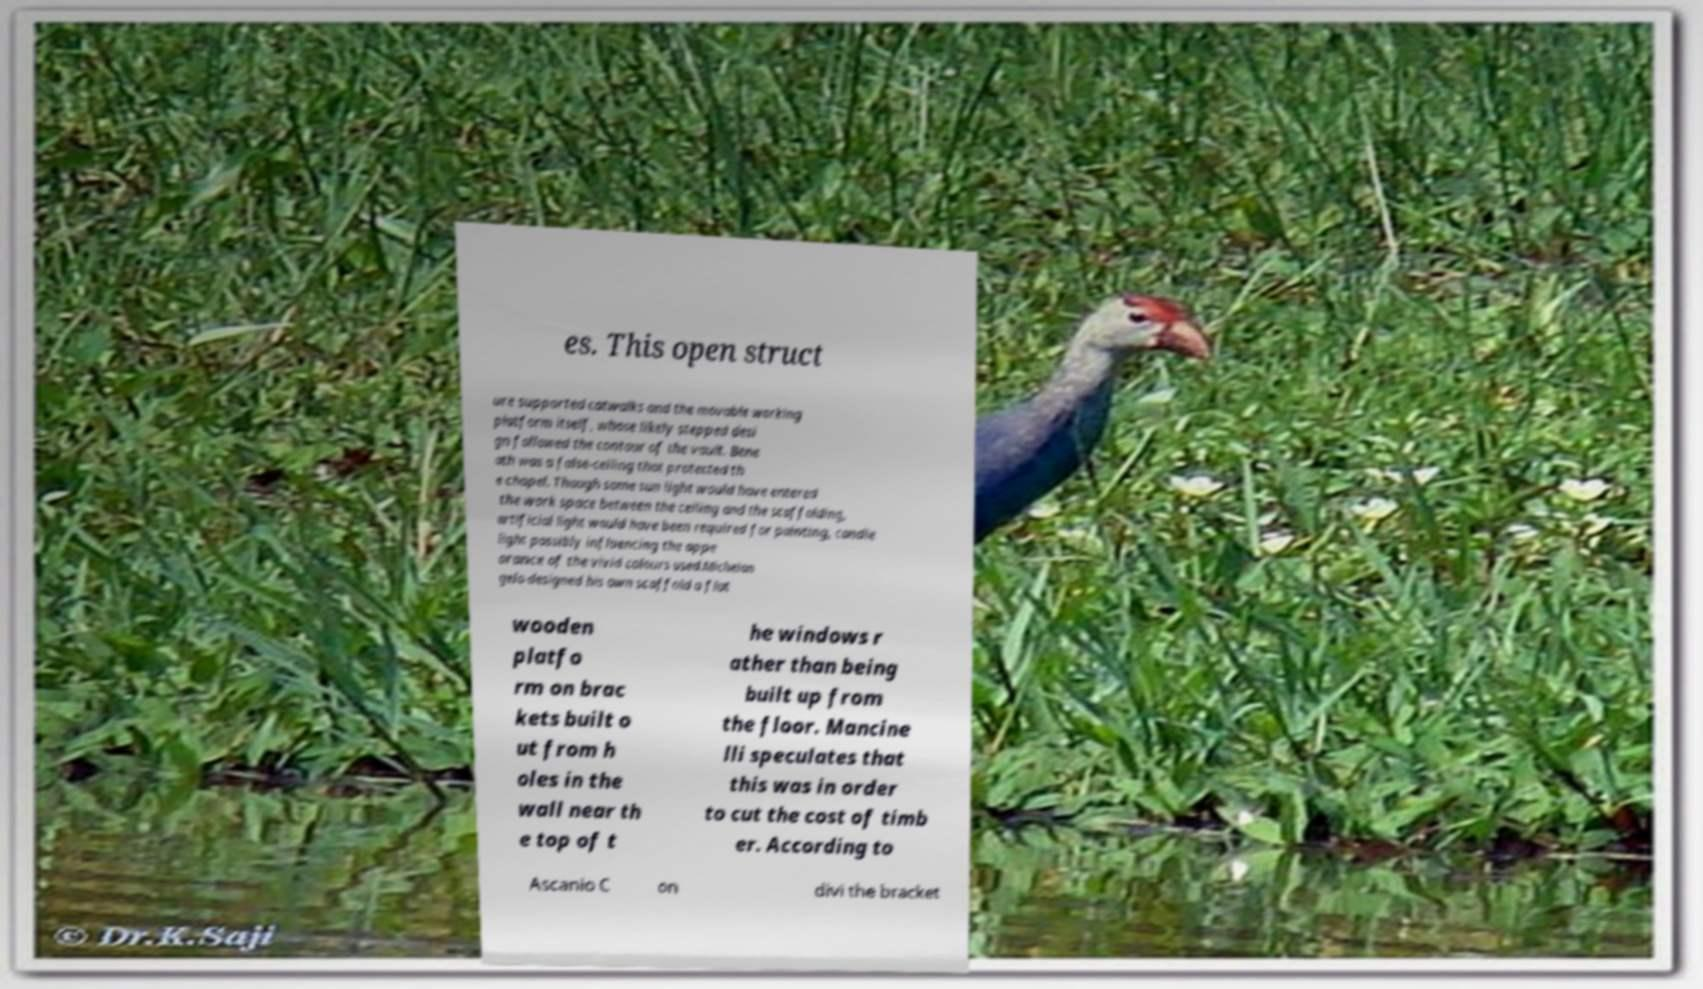What messages or text are displayed in this image? I need them in a readable, typed format. es. This open struct ure supported catwalks and the movable working platform itself, whose likely stepped desi gn followed the contour of the vault. Bene ath was a false-ceiling that protected th e chapel. Though some sun light would have entered the work space between the ceiling and the scaffolding, artificial light would have been required for painting, candle light possibly influencing the appe arance of the vivid colours used.Michelan gelo designed his own scaffold a flat wooden platfo rm on brac kets built o ut from h oles in the wall near th e top of t he windows r ather than being built up from the floor. Mancine lli speculates that this was in order to cut the cost of timb er. According to Ascanio C on divi the bracket 